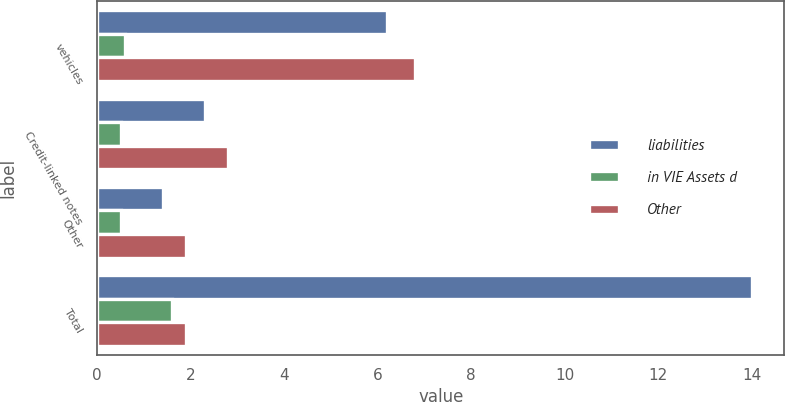Convert chart to OTSL. <chart><loc_0><loc_0><loc_500><loc_500><stacked_bar_chart><ecel><fcel>vehicles<fcel>Credit-linked notes<fcel>Other<fcel>Total<nl><fcel>liabilities<fcel>6.2<fcel>2.3<fcel>1.4<fcel>14<nl><fcel>in VIE Assets d<fcel>0.6<fcel>0.5<fcel>0.5<fcel>1.6<nl><fcel>Other<fcel>6.8<fcel>2.8<fcel>1.9<fcel>1.9<nl></chart> 